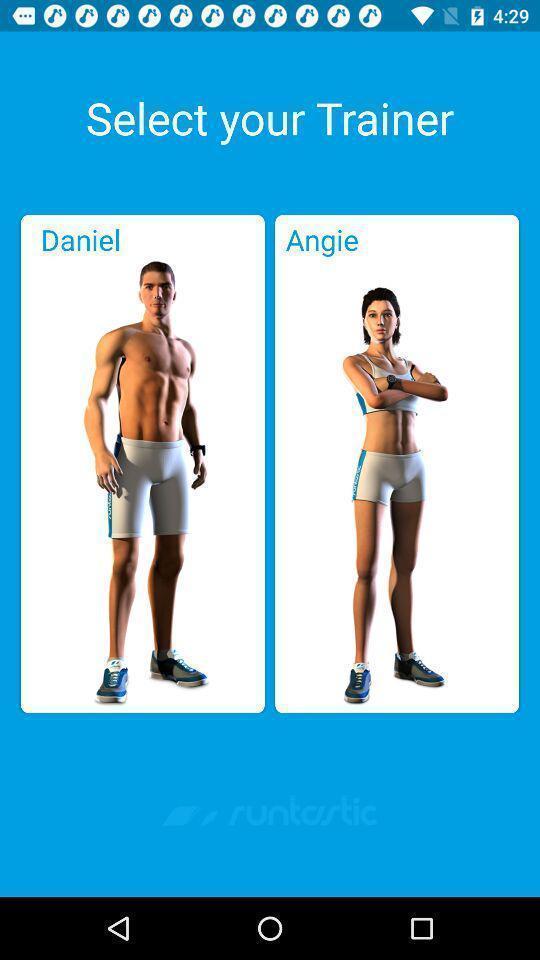Tell me about the visual elements in this screen capture. Page showing options to select. 